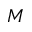<formula> <loc_0><loc_0><loc_500><loc_500>M</formula> 